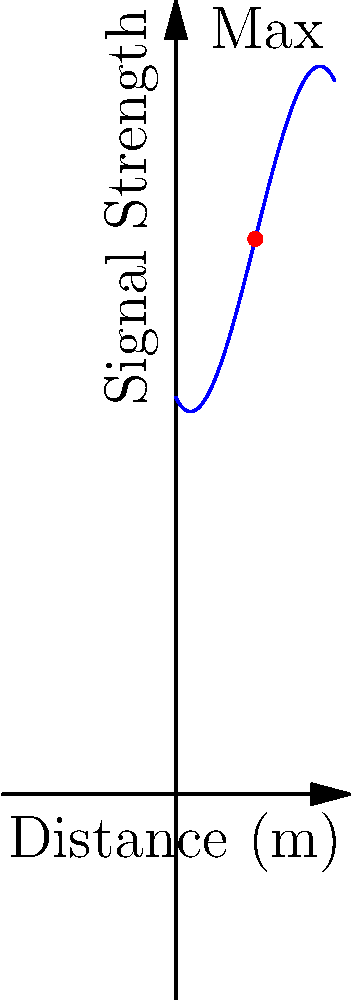You're building a droid and want to optimize its communication system. The signal strength $S$ of your droid's transmitter is modeled by the polynomial function $S(x) = -0.5x^3 + 3x^2 - 2x + 10$, where $x$ is the distance from the droid in meters. At what distance should you position the receiver to get the maximum signal strength? To find the maximum signal strength, we need to follow these steps:

1) The maximum of a polynomial function occurs at a point where its derivative equals zero. So, we need to find $S'(x)$ and set it to zero.

2) $S'(x) = -1.5x^2 + 6x - 2$

3) Set $S'(x) = 0$:
   $-1.5x^2 + 6x - 2 = 0$

4) This is a quadratic equation. We can solve it using the quadratic formula:
   $x = \frac{-b \pm \sqrt{b^2 - 4ac}}{2a}$

   Where $a = -1.5$, $b = 6$, and $c = -2$

5) Plugging in these values:
   $x = \frac{-6 \pm \sqrt{36 - 4(-1.5)(-2)}}{2(-1.5)}$
   $= \frac{-6 \pm \sqrt{36 - 12}}{-3}$
   $= \frac{-6 \pm \sqrt{24}}{-3}$
   $= \frac{-6 \pm 2\sqrt{6}}{-3}$

6) This gives us two solutions:
   $x_1 = \frac{-6 + 2\sqrt{6}}{-3} = 2 - \frac{2\sqrt{6}}{3}$
   $x_2 = \frac{-6 - 2\sqrt{6}}{-3} = 2 + \frac{2\sqrt{6}}{3}$

7) To determine which of these gives the maximum (rather than minimum), we can check the second derivative:
   $S''(x) = -3x + 6$

8) At $x = 2$, $S''(2) = -3(2) + 6 = 0$

9) Since the second derivative is negative for $x > 2$ and positive for $x < 2$, the maximum occurs at $x = 2$.

Therefore, you should position the receiver 2 meters away from the droid to get the maximum signal strength.
Answer: 2 meters 